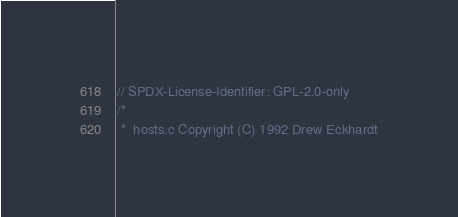<code> <loc_0><loc_0><loc_500><loc_500><_C_>// SPDX-License-Identifier: GPL-2.0-only
/*
 *  hosts.c Copyright (C) 1992 Drew Eckhardt</code> 